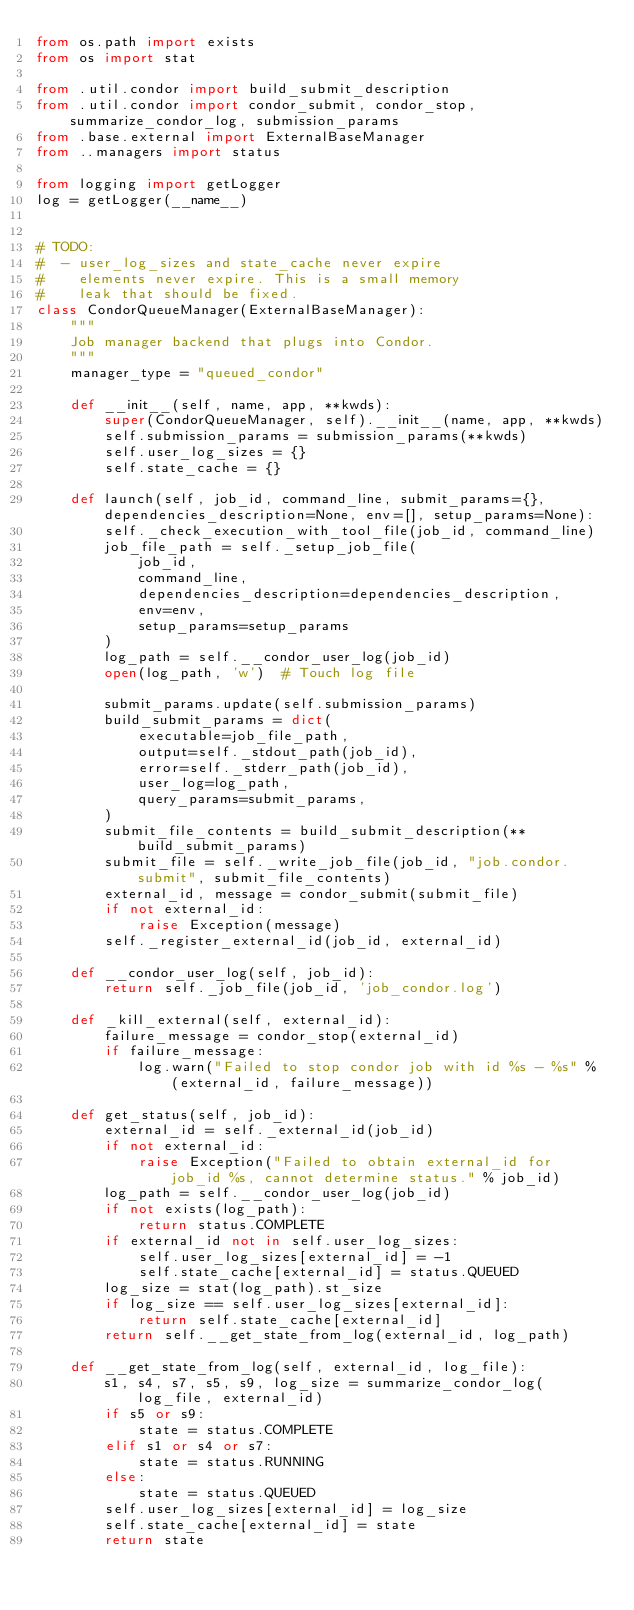<code> <loc_0><loc_0><loc_500><loc_500><_Python_>from os.path import exists
from os import stat

from .util.condor import build_submit_description
from .util.condor import condor_submit, condor_stop, summarize_condor_log, submission_params
from .base.external import ExternalBaseManager
from ..managers import status

from logging import getLogger
log = getLogger(__name__)


# TODO:
#  - user_log_sizes and state_cache never expire
#    elements never expire. This is a small memory
#    leak that should be fixed.
class CondorQueueManager(ExternalBaseManager):
    """
    Job manager backend that plugs into Condor.
    """
    manager_type = "queued_condor"

    def __init__(self, name, app, **kwds):
        super(CondorQueueManager, self).__init__(name, app, **kwds)
        self.submission_params = submission_params(**kwds)
        self.user_log_sizes = {}
        self.state_cache = {}

    def launch(self, job_id, command_line, submit_params={}, dependencies_description=None, env=[], setup_params=None):
        self._check_execution_with_tool_file(job_id, command_line)
        job_file_path = self._setup_job_file(
            job_id,
            command_line,
            dependencies_description=dependencies_description,
            env=env,
            setup_params=setup_params
        )
        log_path = self.__condor_user_log(job_id)
        open(log_path, 'w')  # Touch log file

        submit_params.update(self.submission_params)
        build_submit_params = dict(
            executable=job_file_path,
            output=self._stdout_path(job_id),
            error=self._stderr_path(job_id),
            user_log=log_path,
            query_params=submit_params,
        )
        submit_file_contents = build_submit_description(**build_submit_params)
        submit_file = self._write_job_file(job_id, "job.condor.submit", submit_file_contents)
        external_id, message = condor_submit(submit_file)
        if not external_id:
            raise Exception(message)
        self._register_external_id(job_id, external_id)

    def __condor_user_log(self, job_id):
        return self._job_file(job_id, 'job_condor.log')

    def _kill_external(self, external_id):
        failure_message = condor_stop(external_id)
        if failure_message:
            log.warn("Failed to stop condor job with id %s - %s" % (external_id, failure_message))

    def get_status(self, job_id):
        external_id = self._external_id(job_id)
        if not external_id:
            raise Exception("Failed to obtain external_id for job_id %s, cannot determine status." % job_id)
        log_path = self.__condor_user_log(job_id)
        if not exists(log_path):
            return status.COMPLETE
        if external_id not in self.user_log_sizes:
            self.user_log_sizes[external_id] = -1
            self.state_cache[external_id] = status.QUEUED
        log_size = stat(log_path).st_size
        if log_size == self.user_log_sizes[external_id]:
            return self.state_cache[external_id]
        return self.__get_state_from_log(external_id, log_path)

    def __get_state_from_log(self, external_id, log_file):
        s1, s4, s7, s5, s9, log_size = summarize_condor_log(log_file, external_id)
        if s5 or s9:
            state = status.COMPLETE
        elif s1 or s4 or s7:
            state = status.RUNNING
        else:
            state = status.QUEUED
        self.user_log_sizes[external_id] = log_size
        self.state_cache[external_id] = state
        return state
</code> 